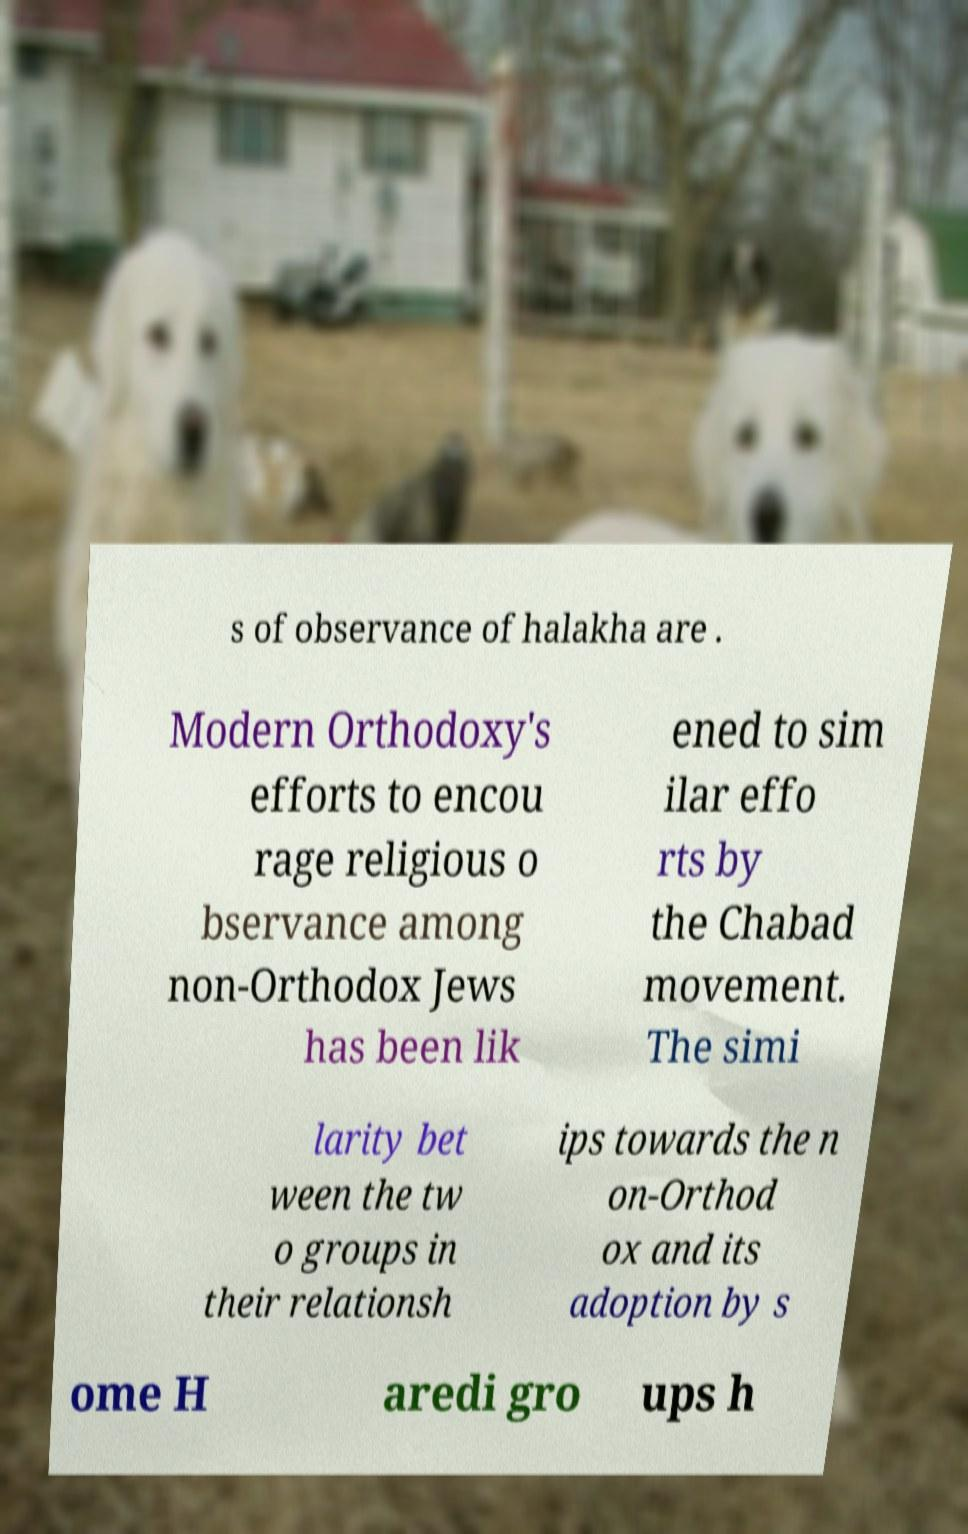I need the written content from this picture converted into text. Can you do that? s of observance of halakha are . Modern Orthodoxy's efforts to encou rage religious o bservance among non-Orthodox Jews has been lik ened to sim ilar effo rts by the Chabad movement. The simi larity bet ween the tw o groups in their relationsh ips towards the n on-Orthod ox and its adoption by s ome H aredi gro ups h 